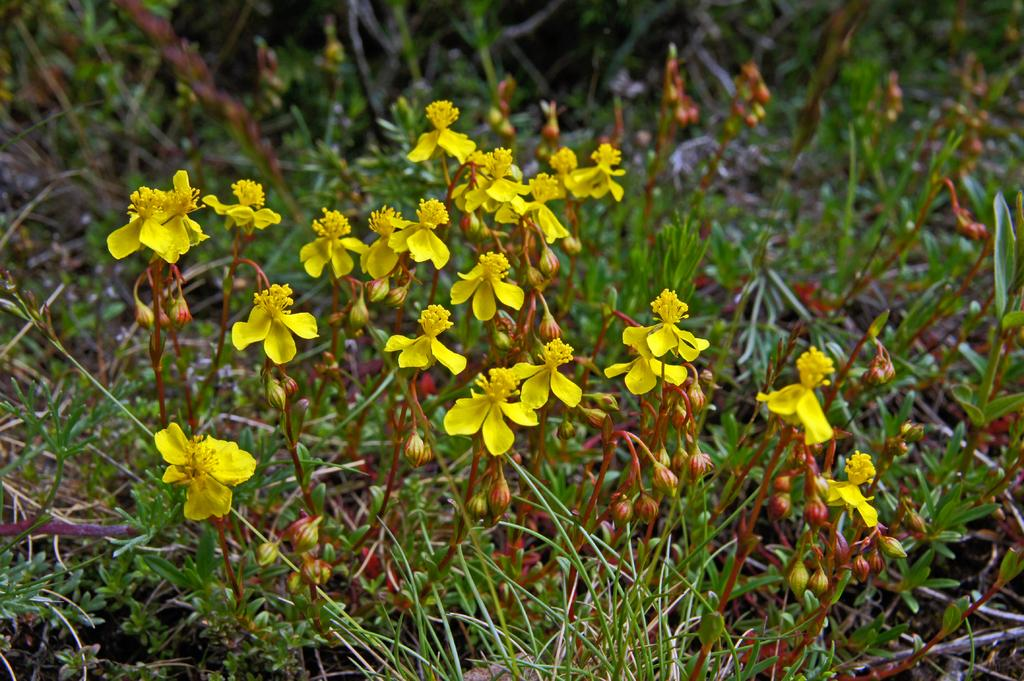What type of living organisms can be seen in the image? Flowers and plants can be seen in the image. What stage of growth are some of the flowers in the image? There are buds in the image, which are flowers in the early stages of growth. Can you describe the plants in the image? The plants in the image have flowers and buds. What type of toothpaste is visible on the plants in the image? There is no toothpaste present on the plants in the image. What color is the veil on the flowers in the image? There is no veil present on the flowers in the image. 